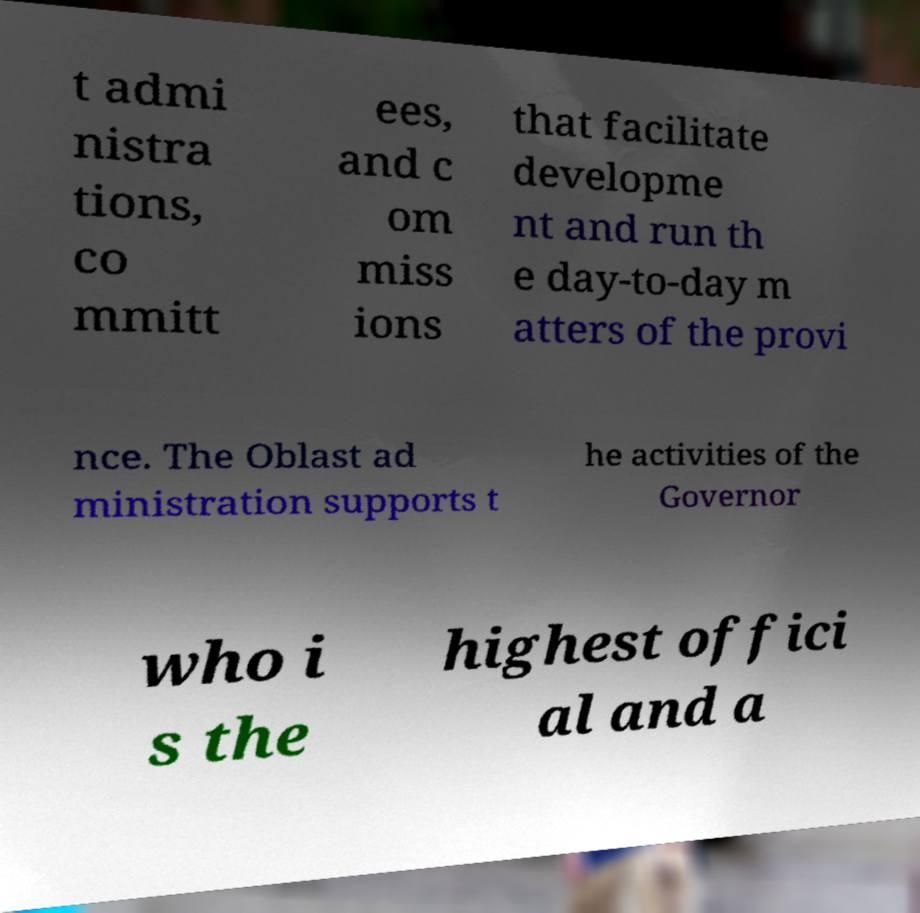Could you extract and type out the text from this image? t admi nistra tions, co mmitt ees, and c om miss ions that facilitate developme nt and run th e day-to-day m atters of the provi nce. The Oblast ad ministration supports t he activities of the Governor who i s the highest offici al and a 